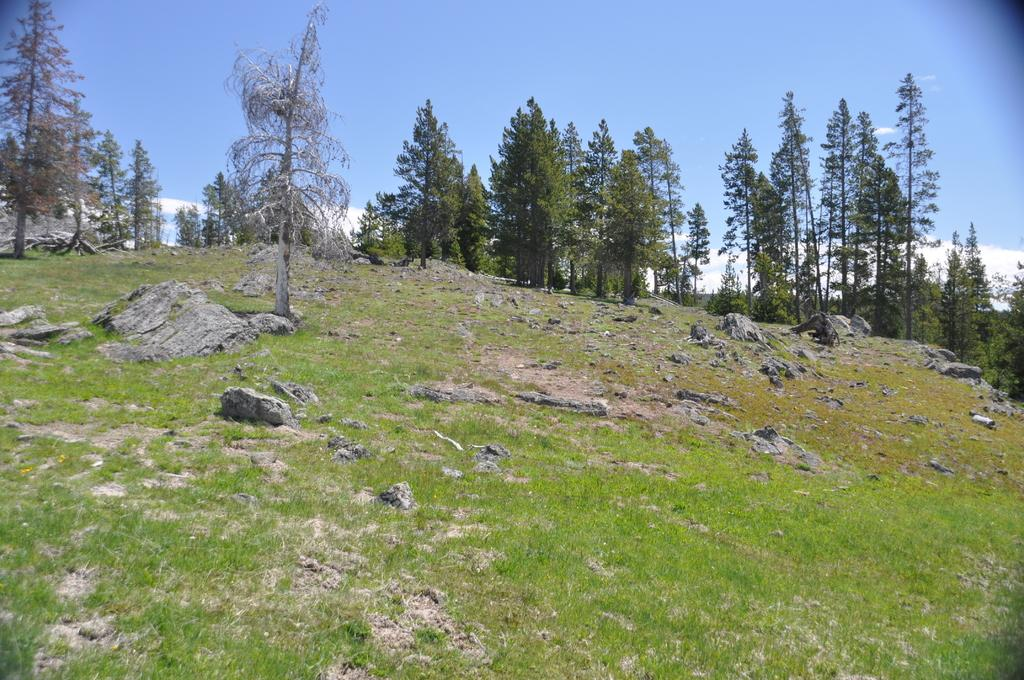What type of vegetation can be seen on the hill in the image? There are trees on a hill in the image. What is visible at the top of the image? The sky is visible at the top of the image. What can be seen in the sky? There are clouds in the sky. What is present at the bottom of the image? Stones and grass are present at the bottom of the image. Can you describe the fight between the father and the snakes in the image? There is no fight between a father and snakes depicted in the image. The image features trees on a hill, clouds in the sky, and stones and grass at the bottom. 